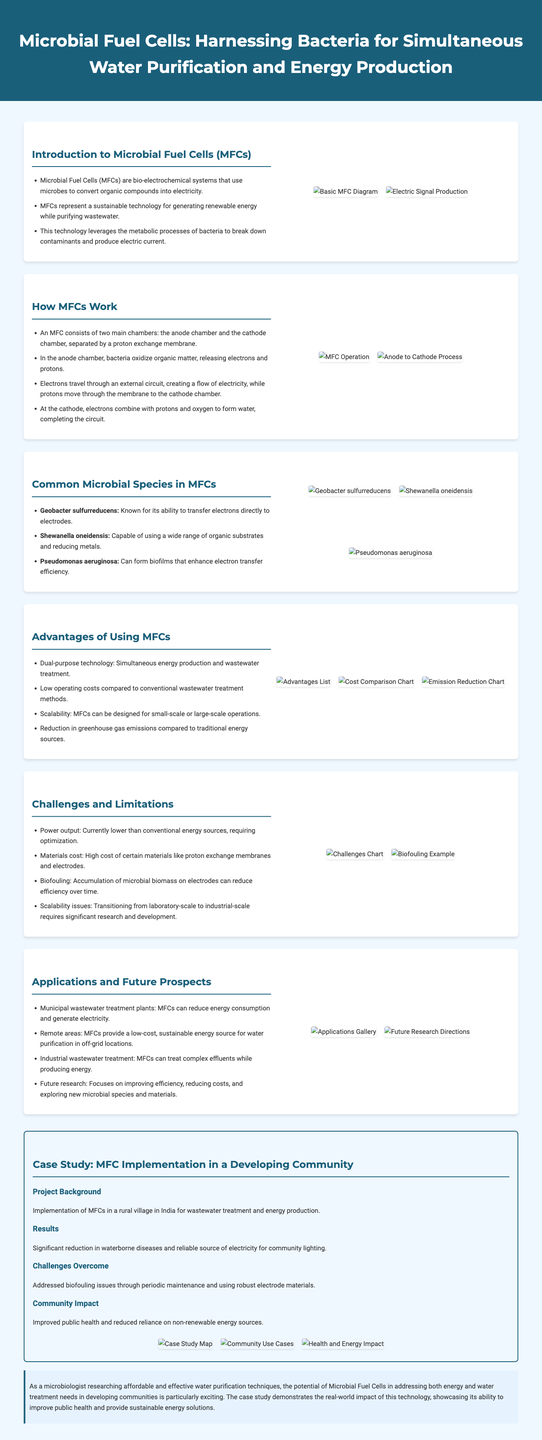What are Microbial Fuel Cells (MFCs)? Microbial Fuel Cells are bio-electrochemical systems that use microbes to convert organic compounds into electricity.
Answer: bio-electrochemical systems What is a common microbial species used in MFCs? The document lists several common microbial species that are used in MFCs, including Geobacter sulfurreducens.
Answer: Geobacter sulfurreducens What are the two main chambers of an MFC? The MFC consists of the anode chamber and the cathode chamber, which are separated by a proton exchange membrane.
Answer: anode chamber and cathode chamber What is a challenge faced by MFCs? High cost of certain materials like proton exchange membranes and electrodes is mentioned as a challenge in the document.
Answer: materials cost How do MFCs contribute to public health? The case study indicates that the implementation of MFCs resulted in a significant reduction in waterborne diseases.
Answer: significant reduction in waterborne diseases What is one advantage of using MFCs over conventional methods? The document states that MFCs have low operating costs compared to conventional wastewater treatment methods.
Answer: low operating costs Which microbial species is capable of using a wide range of organic substrates? The document identifies Shewanella oneidensis as capable of using a wide range of organic substrates.
Answer: Shewanella oneidensis What future research direction is mentioned for MFCs? The focus on improving efficiency is highlighted as a future research direction for MFCs.
Answer: improving efficiency 